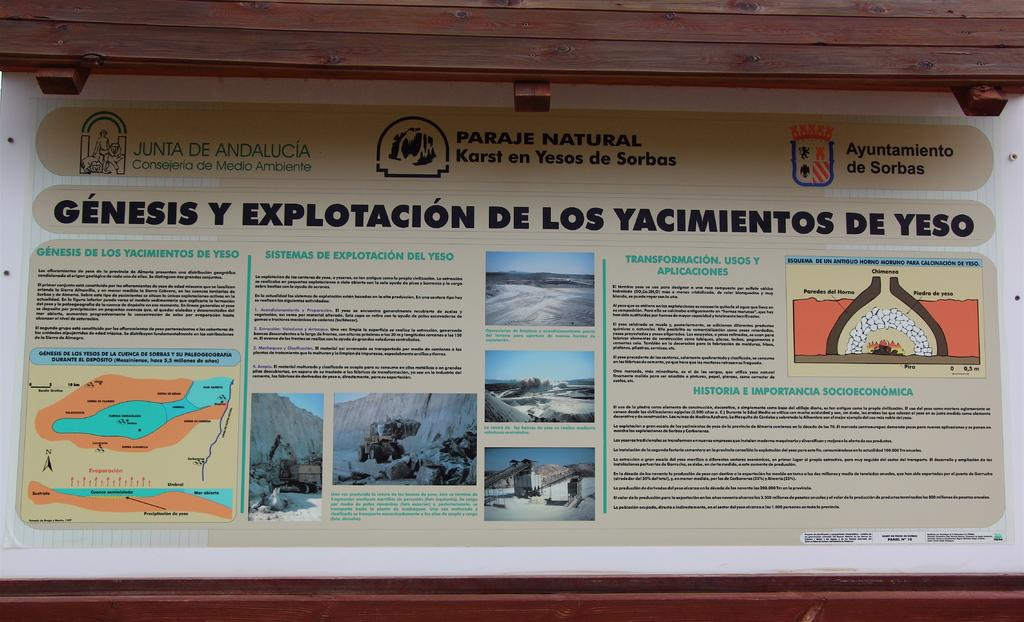<image>
Render a clear and concise summary of the photo. An information pamphlet that says Genesis Explotacion De Los Yacimientos De Yeso on it. 